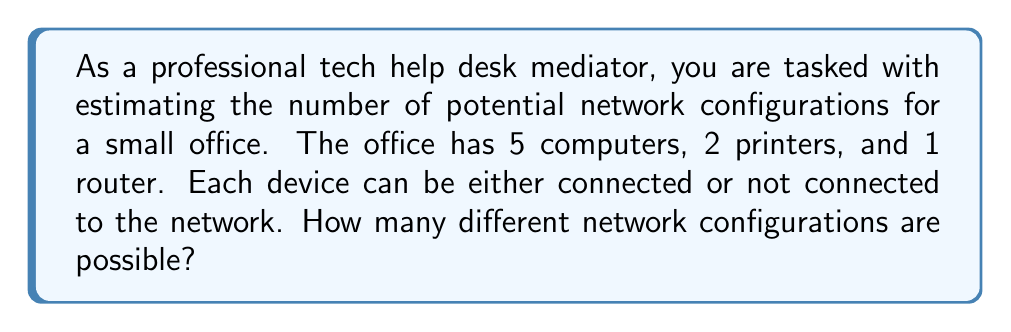Could you help me with this problem? To solve this problem, we need to use the concept of combinatorics. Each device has two possible states: connected or not connected to the network. We can think of this as a binary choice for each device.

1. First, let's count the total number of devices:
   * 5 computers
   * 2 printers
   * 1 router
   Total devices = 5 + 2 + 1 = 8

2. For each device, we have 2 choices (connected or not connected).

3. According to the multiplication principle, if we have a series of independent choices, the total number of possible outcomes is the product of the number of choices for each decision.

4. In this case, we have 8 independent decisions (one for each device), each with 2 possible outcomes.

5. Therefore, the total number of possible network configurations is:

   $$ 2^8 = 2 \times 2 \times 2 \times 2 \times 2 \times 2 \times 2 \times 2 = 256 $$

This means there are 256 different ways the devices can be configured on the network, ranging from all devices disconnected to all devices connected, and every combination in between.
Answer: There are 256 possible network configurations. 